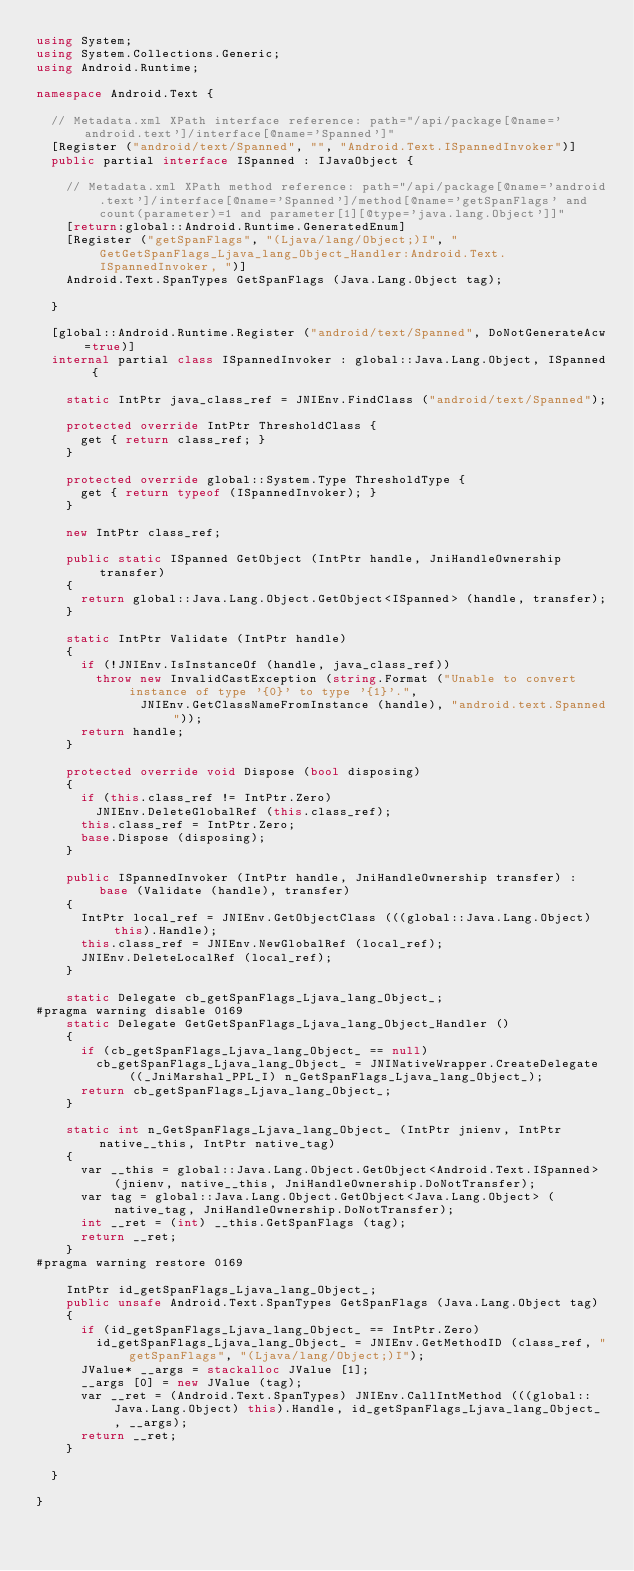<code> <loc_0><loc_0><loc_500><loc_500><_C#_>using System;
using System.Collections.Generic;
using Android.Runtime;

namespace Android.Text {

	// Metadata.xml XPath interface reference: path="/api/package[@name='android.text']/interface[@name='Spanned']"
	[Register ("android/text/Spanned", "", "Android.Text.ISpannedInvoker")]
	public partial interface ISpanned : IJavaObject {

		// Metadata.xml XPath method reference: path="/api/package[@name='android.text']/interface[@name='Spanned']/method[@name='getSpanFlags' and count(parameter)=1 and parameter[1][@type='java.lang.Object']]"
		[return:global::Android.Runtime.GeneratedEnum]
		[Register ("getSpanFlags", "(Ljava/lang/Object;)I", "GetGetSpanFlags_Ljava_lang_Object_Handler:Android.Text.ISpannedInvoker, ")]
		Android.Text.SpanTypes GetSpanFlags (Java.Lang.Object tag);

	}

	[global::Android.Runtime.Register ("android/text/Spanned", DoNotGenerateAcw=true)]
	internal partial class ISpannedInvoker : global::Java.Lang.Object, ISpanned {

		static IntPtr java_class_ref = JNIEnv.FindClass ("android/text/Spanned");

		protected override IntPtr ThresholdClass {
			get { return class_ref; }
		}

		protected override global::System.Type ThresholdType {
			get { return typeof (ISpannedInvoker); }
		}

		new IntPtr class_ref;

		public static ISpanned GetObject (IntPtr handle, JniHandleOwnership transfer)
		{
			return global::Java.Lang.Object.GetObject<ISpanned> (handle, transfer);
		}

		static IntPtr Validate (IntPtr handle)
		{
			if (!JNIEnv.IsInstanceOf (handle, java_class_ref))
				throw new InvalidCastException (string.Format ("Unable to convert instance of type '{0}' to type '{1}'.",
							JNIEnv.GetClassNameFromInstance (handle), "android.text.Spanned"));
			return handle;
		}

		protected override void Dispose (bool disposing)
		{
			if (this.class_ref != IntPtr.Zero)
				JNIEnv.DeleteGlobalRef (this.class_ref);
			this.class_ref = IntPtr.Zero;
			base.Dispose (disposing);
		}

		public ISpannedInvoker (IntPtr handle, JniHandleOwnership transfer) : base (Validate (handle), transfer)
		{
			IntPtr local_ref = JNIEnv.GetObjectClass (((global::Java.Lang.Object) this).Handle);
			this.class_ref = JNIEnv.NewGlobalRef (local_ref);
			JNIEnv.DeleteLocalRef (local_ref);
		}

		static Delegate cb_getSpanFlags_Ljava_lang_Object_;
#pragma warning disable 0169
		static Delegate GetGetSpanFlags_Ljava_lang_Object_Handler ()
		{
			if (cb_getSpanFlags_Ljava_lang_Object_ == null)
				cb_getSpanFlags_Ljava_lang_Object_ = JNINativeWrapper.CreateDelegate ((_JniMarshal_PPL_I) n_GetSpanFlags_Ljava_lang_Object_);
			return cb_getSpanFlags_Ljava_lang_Object_;
		}

		static int n_GetSpanFlags_Ljava_lang_Object_ (IntPtr jnienv, IntPtr native__this, IntPtr native_tag)
		{
			var __this = global::Java.Lang.Object.GetObject<Android.Text.ISpanned> (jnienv, native__this, JniHandleOwnership.DoNotTransfer);
			var tag = global::Java.Lang.Object.GetObject<Java.Lang.Object> (native_tag, JniHandleOwnership.DoNotTransfer);
			int __ret = (int) __this.GetSpanFlags (tag);
			return __ret;
		}
#pragma warning restore 0169

		IntPtr id_getSpanFlags_Ljava_lang_Object_;
		public unsafe Android.Text.SpanTypes GetSpanFlags (Java.Lang.Object tag)
		{
			if (id_getSpanFlags_Ljava_lang_Object_ == IntPtr.Zero)
				id_getSpanFlags_Ljava_lang_Object_ = JNIEnv.GetMethodID (class_ref, "getSpanFlags", "(Ljava/lang/Object;)I");
			JValue* __args = stackalloc JValue [1];
			__args [0] = new JValue (tag);
			var __ret = (Android.Text.SpanTypes) JNIEnv.CallIntMethod (((global::Java.Lang.Object) this).Handle, id_getSpanFlags_Ljava_lang_Object_, __args);
			return __ret;
		}

	}

}
</code> 